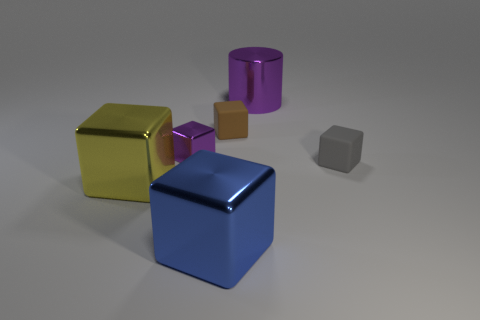Add 2 cubes. How many objects exist? 8 Subtract all blue shiny blocks. How many blocks are left? 4 Subtract all gray blocks. How many blocks are left? 4 Subtract all cylinders. How many objects are left? 5 Subtract 1 cubes. How many cubes are left? 4 Subtract all purple blocks. Subtract all purple cylinders. How many blocks are left? 4 Subtract all small brown matte spheres. Subtract all purple metallic cubes. How many objects are left? 5 Add 3 tiny purple metallic objects. How many tiny purple metallic objects are left? 4 Add 3 brown cubes. How many brown cubes exist? 4 Subtract 1 purple cylinders. How many objects are left? 5 